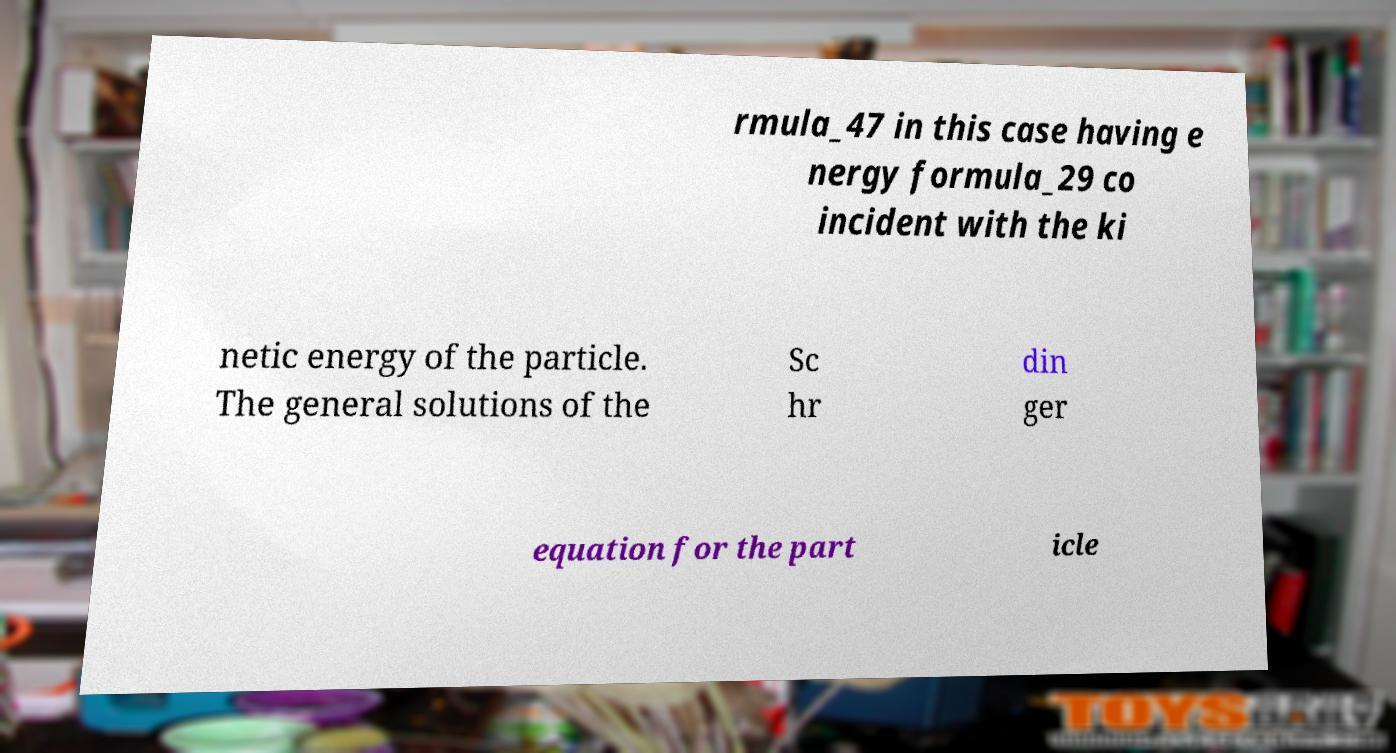Can you read and provide the text displayed in the image?This photo seems to have some interesting text. Can you extract and type it out for me? rmula_47 in this case having e nergy formula_29 co incident with the ki netic energy of the particle. The general solutions of the Sc hr din ger equation for the part icle 